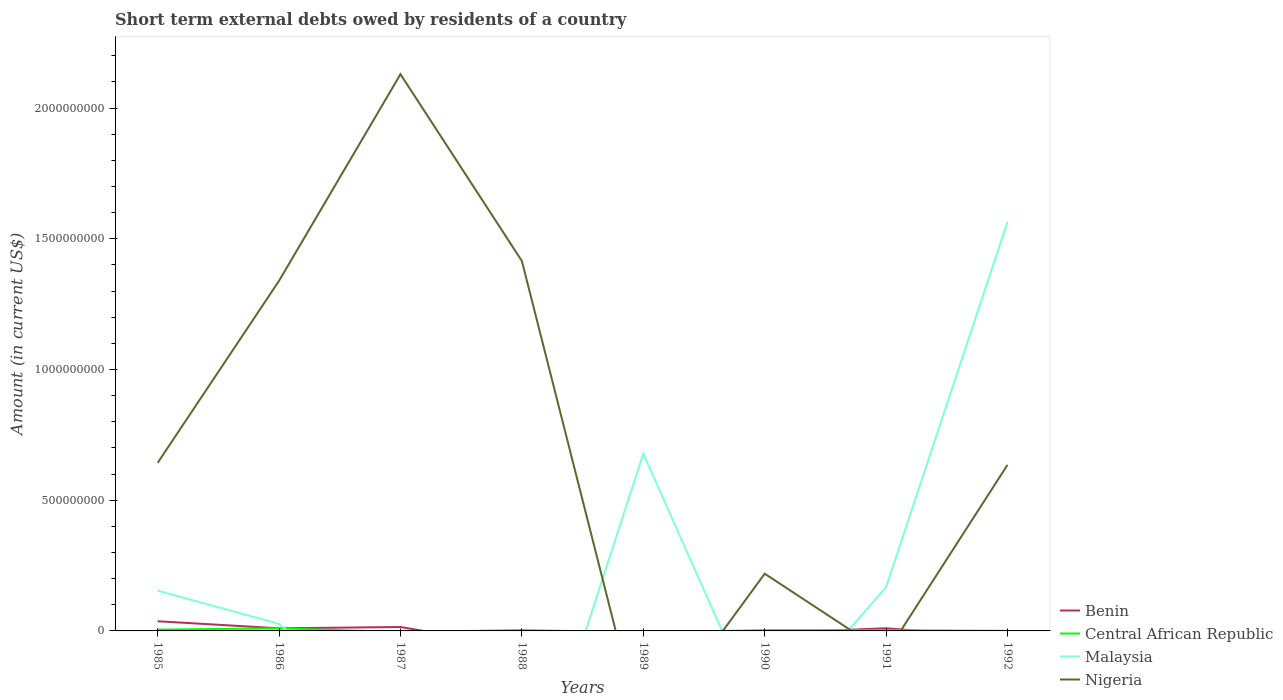Does the line corresponding to Nigeria intersect with the line corresponding to Central African Republic?
Make the answer very short. Yes. Across all years, what is the maximum amount of short-term external debts owed by residents in Benin?
Give a very brief answer. 0. What is the total amount of short-term external debts owed by residents in Benin in the graph?
Keep it short and to the point. -5.00e+06. What is the difference between the highest and the second highest amount of short-term external debts owed by residents in Central African Republic?
Your answer should be very brief. 1.00e+07. What is the difference between the highest and the lowest amount of short-term external debts owed by residents in Central African Republic?
Ensure brevity in your answer.  3. How many lines are there?
Provide a short and direct response. 4. How many years are there in the graph?
Your answer should be very brief. 8. What is the difference between two consecutive major ticks on the Y-axis?
Your answer should be very brief. 5.00e+08. Does the graph contain any zero values?
Give a very brief answer. Yes. Does the graph contain grids?
Offer a terse response. No. Where does the legend appear in the graph?
Your response must be concise. Bottom right. How many legend labels are there?
Provide a short and direct response. 4. What is the title of the graph?
Ensure brevity in your answer.  Short term external debts owed by residents of a country. What is the label or title of the Y-axis?
Make the answer very short. Amount (in current US$). What is the Amount (in current US$) of Benin in 1985?
Make the answer very short. 3.70e+07. What is the Amount (in current US$) in Central African Republic in 1985?
Your response must be concise. 5.00e+06. What is the Amount (in current US$) in Malaysia in 1985?
Provide a short and direct response. 1.54e+08. What is the Amount (in current US$) in Nigeria in 1985?
Offer a terse response. 6.43e+08. What is the Amount (in current US$) in Benin in 1986?
Make the answer very short. 1.00e+07. What is the Amount (in current US$) of Central African Republic in 1986?
Offer a very short reply. 1.00e+07. What is the Amount (in current US$) of Malaysia in 1986?
Give a very brief answer. 2.70e+07. What is the Amount (in current US$) of Nigeria in 1986?
Offer a terse response. 1.34e+09. What is the Amount (in current US$) of Benin in 1987?
Your answer should be compact. 1.50e+07. What is the Amount (in current US$) of Central African Republic in 1987?
Your answer should be very brief. 0. What is the Amount (in current US$) in Nigeria in 1987?
Your response must be concise. 2.13e+09. What is the Amount (in current US$) in Central African Republic in 1988?
Give a very brief answer. 3.33e+06. What is the Amount (in current US$) in Nigeria in 1988?
Your answer should be compact. 1.41e+09. What is the Amount (in current US$) of Central African Republic in 1989?
Your answer should be compact. 0. What is the Amount (in current US$) in Malaysia in 1989?
Your answer should be compact. 6.78e+08. What is the Amount (in current US$) of Benin in 1990?
Provide a short and direct response. 0. What is the Amount (in current US$) of Central African Republic in 1990?
Provide a succinct answer. 2.91e+06. What is the Amount (in current US$) of Nigeria in 1990?
Ensure brevity in your answer.  2.19e+08. What is the Amount (in current US$) in Benin in 1991?
Make the answer very short. 1.01e+07. What is the Amount (in current US$) in Central African Republic in 1991?
Ensure brevity in your answer.  3.00e+06. What is the Amount (in current US$) in Malaysia in 1991?
Give a very brief answer. 1.68e+08. What is the Amount (in current US$) of Nigeria in 1991?
Provide a succinct answer. 0. What is the Amount (in current US$) of Malaysia in 1992?
Your answer should be very brief. 1.57e+09. What is the Amount (in current US$) of Nigeria in 1992?
Offer a terse response. 6.35e+08. Across all years, what is the maximum Amount (in current US$) of Benin?
Your response must be concise. 3.70e+07. Across all years, what is the maximum Amount (in current US$) in Malaysia?
Your answer should be compact. 1.57e+09. Across all years, what is the maximum Amount (in current US$) of Nigeria?
Provide a succinct answer. 2.13e+09. Across all years, what is the minimum Amount (in current US$) in Malaysia?
Keep it short and to the point. 0. Across all years, what is the minimum Amount (in current US$) of Nigeria?
Keep it short and to the point. 0. What is the total Amount (in current US$) of Benin in the graph?
Provide a succinct answer. 7.21e+07. What is the total Amount (in current US$) in Central African Republic in the graph?
Your answer should be compact. 2.45e+07. What is the total Amount (in current US$) in Malaysia in the graph?
Provide a succinct answer. 2.59e+09. What is the total Amount (in current US$) of Nigeria in the graph?
Offer a very short reply. 6.38e+09. What is the difference between the Amount (in current US$) of Benin in 1985 and that in 1986?
Your answer should be very brief. 2.70e+07. What is the difference between the Amount (in current US$) in Central African Republic in 1985 and that in 1986?
Your answer should be compact. -5.00e+06. What is the difference between the Amount (in current US$) in Malaysia in 1985 and that in 1986?
Ensure brevity in your answer.  1.27e+08. What is the difference between the Amount (in current US$) of Nigeria in 1985 and that in 1986?
Give a very brief answer. -6.96e+08. What is the difference between the Amount (in current US$) of Benin in 1985 and that in 1987?
Provide a short and direct response. 2.20e+07. What is the difference between the Amount (in current US$) in Nigeria in 1985 and that in 1987?
Give a very brief answer. -1.49e+09. What is the difference between the Amount (in current US$) in Central African Republic in 1985 and that in 1988?
Provide a succinct answer. 1.67e+06. What is the difference between the Amount (in current US$) of Nigeria in 1985 and that in 1988?
Give a very brief answer. -7.72e+08. What is the difference between the Amount (in current US$) in Malaysia in 1985 and that in 1989?
Give a very brief answer. -5.24e+08. What is the difference between the Amount (in current US$) in Central African Republic in 1985 and that in 1990?
Give a very brief answer. 2.09e+06. What is the difference between the Amount (in current US$) in Nigeria in 1985 and that in 1990?
Offer a terse response. 4.24e+08. What is the difference between the Amount (in current US$) in Benin in 1985 and that in 1991?
Offer a terse response. 2.69e+07. What is the difference between the Amount (in current US$) in Malaysia in 1985 and that in 1991?
Offer a very short reply. -1.38e+07. What is the difference between the Amount (in current US$) of Central African Republic in 1985 and that in 1992?
Offer a very short reply. 4.70e+06. What is the difference between the Amount (in current US$) in Malaysia in 1985 and that in 1992?
Give a very brief answer. -1.41e+09. What is the difference between the Amount (in current US$) of Nigeria in 1985 and that in 1992?
Keep it short and to the point. 7.87e+06. What is the difference between the Amount (in current US$) in Benin in 1986 and that in 1987?
Your answer should be very brief. -5.00e+06. What is the difference between the Amount (in current US$) of Nigeria in 1986 and that in 1987?
Keep it short and to the point. -7.90e+08. What is the difference between the Amount (in current US$) in Central African Republic in 1986 and that in 1988?
Your answer should be compact. 6.67e+06. What is the difference between the Amount (in current US$) in Nigeria in 1986 and that in 1988?
Offer a very short reply. -7.55e+07. What is the difference between the Amount (in current US$) in Malaysia in 1986 and that in 1989?
Your response must be concise. -6.51e+08. What is the difference between the Amount (in current US$) of Central African Republic in 1986 and that in 1990?
Give a very brief answer. 7.09e+06. What is the difference between the Amount (in current US$) of Nigeria in 1986 and that in 1990?
Provide a short and direct response. 1.12e+09. What is the difference between the Amount (in current US$) in Malaysia in 1986 and that in 1991?
Make the answer very short. -1.41e+08. What is the difference between the Amount (in current US$) of Central African Republic in 1986 and that in 1992?
Make the answer very short. 9.70e+06. What is the difference between the Amount (in current US$) in Malaysia in 1986 and that in 1992?
Make the answer very short. -1.54e+09. What is the difference between the Amount (in current US$) of Nigeria in 1986 and that in 1992?
Give a very brief answer. 7.04e+08. What is the difference between the Amount (in current US$) in Nigeria in 1987 and that in 1988?
Ensure brevity in your answer.  7.15e+08. What is the difference between the Amount (in current US$) in Nigeria in 1987 and that in 1990?
Your response must be concise. 1.91e+09. What is the difference between the Amount (in current US$) in Benin in 1987 and that in 1991?
Ensure brevity in your answer.  4.89e+06. What is the difference between the Amount (in current US$) of Nigeria in 1987 and that in 1992?
Provide a short and direct response. 1.49e+09. What is the difference between the Amount (in current US$) of Nigeria in 1988 and that in 1990?
Offer a terse response. 1.20e+09. What is the difference between the Amount (in current US$) of Central African Republic in 1988 and that in 1992?
Your answer should be very brief. 3.03e+06. What is the difference between the Amount (in current US$) of Nigeria in 1988 and that in 1992?
Keep it short and to the point. 7.80e+08. What is the difference between the Amount (in current US$) of Malaysia in 1989 and that in 1991?
Your response must be concise. 5.10e+08. What is the difference between the Amount (in current US$) of Malaysia in 1989 and that in 1992?
Make the answer very short. -8.87e+08. What is the difference between the Amount (in current US$) of Central African Republic in 1990 and that in 1991?
Your answer should be very brief. -9.00e+04. What is the difference between the Amount (in current US$) of Central African Republic in 1990 and that in 1992?
Provide a short and direct response. 2.61e+06. What is the difference between the Amount (in current US$) of Nigeria in 1990 and that in 1992?
Offer a terse response. -4.16e+08. What is the difference between the Amount (in current US$) of Central African Republic in 1991 and that in 1992?
Keep it short and to the point. 2.70e+06. What is the difference between the Amount (in current US$) of Malaysia in 1991 and that in 1992?
Your response must be concise. -1.40e+09. What is the difference between the Amount (in current US$) of Benin in 1985 and the Amount (in current US$) of Central African Republic in 1986?
Provide a succinct answer. 2.70e+07. What is the difference between the Amount (in current US$) of Benin in 1985 and the Amount (in current US$) of Malaysia in 1986?
Your response must be concise. 1.00e+07. What is the difference between the Amount (in current US$) in Benin in 1985 and the Amount (in current US$) in Nigeria in 1986?
Give a very brief answer. -1.30e+09. What is the difference between the Amount (in current US$) of Central African Republic in 1985 and the Amount (in current US$) of Malaysia in 1986?
Your response must be concise. -2.20e+07. What is the difference between the Amount (in current US$) in Central African Republic in 1985 and the Amount (in current US$) in Nigeria in 1986?
Give a very brief answer. -1.33e+09. What is the difference between the Amount (in current US$) of Malaysia in 1985 and the Amount (in current US$) of Nigeria in 1986?
Provide a short and direct response. -1.19e+09. What is the difference between the Amount (in current US$) of Benin in 1985 and the Amount (in current US$) of Nigeria in 1987?
Keep it short and to the point. -2.09e+09. What is the difference between the Amount (in current US$) in Central African Republic in 1985 and the Amount (in current US$) in Nigeria in 1987?
Offer a very short reply. -2.12e+09. What is the difference between the Amount (in current US$) of Malaysia in 1985 and the Amount (in current US$) of Nigeria in 1987?
Provide a succinct answer. -1.98e+09. What is the difference between the Amount (in current US$) in Benin in 1985 and the Amount (in current US$) in Central African Republic in 1988?
Provide a short and direct response. 3.37e+07. What is the difference between the Amount (in current US$) in Benin in 1985 and the Amount (in current US$) in Nigeria in 1988?
Provide a short and direct response. -1.38e+09. What is the difference between the Amount (in current US$) of Central African Republic in 1985 and the Amount (in current US$) of Nigeria in 1988?
Make the answer very short. -1.41e+09. What is the difference between the Amount (in current US$) of Malaysia in 1985 and the Amount (in current US$) of Nigeria in 1988?
Provide a short and direct response. -1.26e+09. What is the difference between the Amount (in current US$) in Benin in 1985 and the Amount (in current US$) in Malaysia in 1989?
Your response must be concise. -6.41e+08. What is the difference between the Amount (in current US$) of Central African Republic in 1985 and the Amount (in current US$) of Malaysia in 1989?
Offer a terse response. -6.73e+08. What is the difference between the Amount (in current US$) in Benin in 1985 and the Amount (in current US$) in Central African Republic in 1990?
Ensure brevity in your answer.  3.41e+07. What is the difference between the Amount (in current US$) of Benin in 1985 and the Amount (in current US$) of Nigeria in 1990?
Provide a succinct answer. -1.82e+08. What is the difference between the Amount (in current US$) of Central African Republic in 1985 and the Amount (in current US$) of Nigeria in 1990?
Provide a short and direct response. -2.14e+08. What is the difference between the Amount (in current US$) in Malaysia in 1985 and the Amount (in current US$) in Nigeria in 1990?
Offer a very short reply. -6.49e+07. What is the difference between the Amount (in current US$) of Benin in 1985 and the Amount (in current US$) of Central African Republic in 1991?
Provide a short and direct response. 3.40e+07. What is the difference between the Amount (in current US$) of Benin in 1985 and the Amount (in current US$) of Malaysia in 1991?
Give a very brief answer. -1.31e+08. What is the difference between the Amount (in current US$) of Central African Republic in 1985 and the Amount (in current US$) of Malaysia in 1991?
Give a very brief answer. -1.63e+08. What is the difference between the Amount (in current US$) in Benin in 1985 and the Amount (in current US$) in Central African Republic in 1992?
Offer a very short reply. 3.67e+07. What is the difference between the Amount (in current US$) of Benin in 1985 and the Amount (in current US$) of Malaysia in 1992?
Your response must be concise. -1.53e+09. What is the difference between the Amount (in current US$) of Benin in 1985 and the Amount (in current US$) of Nigeria in 1992?
Offer a terse response. -5.98e+08. What is the difference between the Amount (in current US$) in Central African Republic in 1985 and the Amount (in current US$) in Malaysia in 1992?
Your response must be concise. -1.56e+09. What is the difference between the Amount (in current US$) in Central African Republic in 1985 and the Amount (in current US$) in Nigeria in 1992?
Make the answer very short. -6.30e+08. What is the difference between the Amount (in current US$) of Malaysia in 1985 and the Amount (in current US$) of Nigeria in 1992?
Your answer should be compact. -4.81e+08. What is the difference between the Amount (in current US$) of Benin in 1986 and the Amount (in current US$) of Nigeria in 1987?
Your answer should be compact. -2.12e+09. What is the difference between the Amount (in current US$) in Central African Republic in 1986 and the Amount (in current US$) in Nigeria in 1987?
Ensure brevity in your answer.  -2.12e+09. What is the difference between the Amount (in current US$) of Malaysia in 1986 and the Amount (in current US$) of Nigeria in 1987?
Give a very brief answer. -2.10e+09. What is the difference between the Amount (in current US$) of Benin in 1986 and the Amount (in current US$) of Central African Republic in 1988?
Your answer should be very brief. 6.67e+06. What is the difference between the Amount (in current US$) of Benin in 1986 and the Amount (in current US$) of Nigeria in 1988?
Provide a short and direct response. -1.40e+09. What is the difference between the Amount (in current US$) in Central African Republic in 1986 and the Amount (in current US$) in Nigeria in 1988?
Your response must be concise. -1.40e+09. What is the difference between the Amount (in current US$) in Malaysia in 1986 and the Amount (in current US$) in Nigeria in 1988?
Your response must be concise. -1.39e+09. What is the difference between the Amount (in current US$) of Benin in 1986 and the Amount (in current US$) of Malaysia in 1989?
Offer a terse response. -6.68e+08. What is the difference between the Amount (in current US$) in Central African Republic in 1986 and the Amount (in current US$) in Malaysia in 1989?
Ensure brevity in your answer.  -6.68e+08. What is the difference between the Amount (in current US$) of Benin in 1986 and the Amount (in current US$) of Central African Republic in 1990?
Keep it short and to the point. 7.09e+06. What is the difference between the Amount (in current US$) in Benin in 1986 and the Amount (in current US$) in Nigeria in 1990?
Make the answer very short. -2.09e+08. What is the difference between the Amount (in current US$) in Central African Republic in 1986 and the Amount (in current US$) in Nigeria in 1990?
Your answer should be very brief. -2.09e+08. What is the difference between the Amount (in current US$) in Malaysia in 1986 and the Amount (in current US$) in Nigeria in 1990?
Your answer should be compact. -1.92e+08. What is the difference between the Amount (in current US$) of Benin in 1986 and the Amount (in current US$) of Central African Republic in 1991?
Ensure brevity in your answer.  7.00e+06. What is the difference between the Amount (in current US$) in Benin in 1986 and the Amount (in current US$) in Malaysia in 1991?
Give a very brief answer. -1.58e+08. What is the difference between the Amount (in current US$) in Central African Republic in 1986 and the Amount (in current US$) in Malaysia in 1991?
Make the answer very short. -1.58e+08. What is the difference between the Amount (in current US$) of Benin in 1986 and the Amount (in current US$) of Central African Republic in 1992?
Offer a very short reply. 9.70e+06. What is the difference between the Amount (in current US$) of Benin in 1986 and the Amount (in current US$) of Malaysia in 1992?
Provide a succinct answer. -1.56e+09. What is the difference between the Amount (in current US$) of Benin in 1986 and the Amount (in current US$) of Nigeria in 1992?
Offer a terse response. -6.25e+08. What is the difference between the Amount (in current US$) in Central African Republic in 1986 and the Amount (in current US$) in Malaysia in 1992?
Offer a very short reply. -1.56e+09. What is the difference between the Amount (in current US$) in Central African Republic in 1986 and the Amount (in current US$) in Nigeria in 1992?
Your answer should be compact. -6.25e+08. What is the difference between the Amount (in current US$) in Malaysia in 1986 and the Amount (in current US$) in Nigeria in 1992?
Your answer should be compact. -6.08e+08. What is the difference between the Amount (in current US$) in Benin in 1987 and the Amount (in current US$) in Central African Republic in 1988?
Your response must be concise. 1.17e+07. What is the difference between the Amount (in current US$) of Benin in 1987 and the Amount (in current US$) of Nigeria in 1988?
Offer a terse response. -1.40e+09. What is the difference between the Amount (in current US$) of Benin in 1987 and the Amount (in current US$) of Malaysia in 1989?
Your answer should be very brief. -6.63e+08. What is the difference between the Amount (in current US$) of Benin in 1987 and the Amount (in current US$) of Central African Republic in 1990?
Provide a short and direct response. 1.21e+07. What is the difference between the Amount (in current US$) of Benin in 1987 and the Amount (in current US$) of Nigeria in 1990?
Make the answer very short. -2.04e+08. What is the difference between the Amount (in current US$) in Benin in 1987 and the Amount (in current US$) in Malaysia in 1991?
Offer a terse response. -1.53e+08. What is the difference between the Amount (in current US$) of Benin in 1987 and the Amount (in current US$) of Central African Republic in 1992?
Provide a short and direct response. 1.47e+07. What is the difference between the Amount (in current US$) in Benin in 1987 and the Amount (in current US$) in Malaysia in 1992?
Offer a terse response. -1.55e+09. What is the difference between the Amount (in current US$) in Benin in 1987 and the Amount (in current US$) in Nigeria in 1992?
Make the answer very short. -6.20e+08. What is the difference between the Amount (in current US$) of Central African Republic in 1988 and the Amount (in current US$) of Malaysia in 1989?
Give a very brief answer. -6.75e+08. What is the difference between the Amount (in current US$) of Central African Republic in 1988 and the Amount (in current US$) of Nigeria in 1990?
Make the answer very short. -2.16e+08. What is the difference between the Amount (in current US$) in Central African Republic in 1988 and the Amount (in current US$) in Malaysia in 1991?
Keep it short and to the point. -1.65e+08. What is the difference between the Amount (in current US$) of Central African Republic in 1988 and the Amount (in current US$) of Malaysia in 1992?
Make the answer very short. -1.56e+09. What is the difference between the Amount (in current US$) of Central African Republic in 1988 and the Amount (in current US$) of Nigeria in 1992?
Ensure brevity in your answer.  -6.32e+08. What is the difference between the Amount (in current US$) in Malaysia in 1989 and the Amount (in current US$) in Nigeria in 1990?
Your answer should be very brief. 4.59e+08. What is the difference between the Amount (in current US$) in Malaysia in 1989 and the Amount (in current US$) in Nigeria in 1992?
Provide a succinct answer. 4.28e+07. What is the difference between the Amount (in current US$) in Central African Republic in 1990 and the Amount (in current US$) in Malaysia in 1991?
Your answer should be very brief. -1.65e+08. What is the difference between the Amount (in current US$) in Central African Republic in 1990 and the Amount (in current US$) in Malaysia in 1992?
Your answer should be compact. -1.56e+09. What is the difference between the Amount (in current US$) in Central African Republic in 1990 and the Amount (in current US$) in Nigeria in 1992?
Your answer should be very brief. -6.32e+08. What is the difference between the Amount (in current US$) of Benin in 1991 and the Amount (in current US$) of Central African Republic in 1992?
Ensure brevity in your answer.  9.81e+06. What is the difference between the Amount (in current US$) in Benin in 1991 and the Amount (in current US$) in Malaysia in 1992?
Make the answer very short. -1.56e+09. What is the difference between the Amount (in current US$) of Benin in 1991 and the Amount (in current US$) of Nigeria in 1992?
Your response must be concise. -6.25e+08. What is the difference between the Amount (in current US$) in Central African Republic in 1991 and the Amount (in current US$) in Malaysia in 1992?
Make the answer very short. -1.56e+09. What is the difference between the Amount (in current US$) of Central African Republic in 1991 and the Amount (in current US$) of Nigeria in 1992?
Offer a very short reply. -6.32e+08. What is the difference between the Amount (in current US$) of Malaysia in 1991 and the Amount (in current US$) of Nigeria in 1992?
Provide a short and direct response. -4.67e+08. What is the average Amount (in current US$) in Benin per year?
Provide a short and direct response. 9.01e+06. What is the average Amount (in current US$) of Central African Republic per year?
Give a very brief answer. 3.07e+06. What is the average Amount (in current US$) in Malaysia per year?
Keep it short and to the point. 3.24e+08. What is the average Amount (in current US$) in Nigeria per year?
Keep it short and to the point. 7.98e+08. In the year 1985, what is the difference between the Amount (in current US$) in Benin and Amount (in current US$) in Central African Republic?
Make the answer very short. 3.20e+07. In the year 1985, what is the difference between the Amount (in current US$) of Benin and Amount (in current US$) of Malaysia?
Offer a terse response. -1.17e+08. In the year 1985, what is the difference between the Amount (in current US$) of Benin and Amount (in current US$) of Nigeria?
Offer a terse response. -6.06e+08. In the year 1985, what is the difference between the Amount (in current US$) in Central African Republic and Amount (in current US$) in Malaysia?
Ensure brevity in your answer.  -1.49e+08. In the year 1985, what is the difference between the Amount (in current US$) of Central African Republic and Amount (in current US$) of Nigeria?
Your answer should be very brief. -6.38e+08. In the year 1985, what is the difference between the Amount (in current US$) of Malaysia and Amount (in current US$) of Nigeria?
Provide a short and direct response. -4.89e+08. In the year 1986, what is the difference between the Amount (in current US$) of Benin and Amount (in current US$) of Malaysia?
Provide a short and direct response. -1.70e+07. In the year 1986, what is the difference between the Amount (in current US$) of Benin and Amount (in current US$) of Nigeria?
Ensure brevity in your answer.  -1.33e+09. In the year 1986, what is the difference between the Amount (in current US$) of Central African Republic and Amount (in current US$) of Malaysia?
Offer a terse response. -1.70e+07. In the year 1986, what is the difference between the Amount (in current US$) in Central African Republic and Amount (in current US$) in Nigeria?
Make the answer very short. -1.33e+09. In the year 1986, what is the difference between the Amount (in current US$) of Malaysia and Amount (in current US$) of Nigeria?
Your answer should be very brief. -1.31e+09. In the year 1987, what is the difference between the Amount (in current US$) of Benin and Amount (in current US$) of Nigeria?
Provide a succinct answer. -2.11e+09. In the year 1988, what is the difference between the Amount (in current US$) in Central African Republic and Amount (in current US$) in Nigeria?
Provide a short and direct response. -1.41e+09. In the year 1990, what is the difference between the Amount (in current US$) in Central African Republic and Amount (in current US$) in Nigeria?
Your answer should be compact. -2.16e+08. In the year 1991, what is the difference between the Amount (in current US$) of Benin and Amount (in current US$) of Central African Republic?
Offer a terse response. 7.11e+06. In the year 1991, what is the difference between the Amount (in current US$) in Benin and Amount (in current US$) in Malaysia?
Keep it short and to the point. -1.58e+08. In the year 1991, what is the difference between the Amount (in current US$) of Central African Republic and Amount (in current US$) of Malaysia?
Keep it short and to the point. -1.65e+08. In the year 1992, what is the difference between the Amount (in current US$) of Central African Republic and Amount (in current US$) of Malaysia?
Your answer should be very brief. -1.56e+09. In the year 1992, what is the difference between the Amount (in current US$) of Central African Republic and Amount (in current US$) of Nigeria?
Your answer should be compact. -6.35e+08. In the year 1992, what is the difference between the Amount (in current US$) of Malaysia and Amount (in current US$) of Nigeria?
Your response must be concise. 9.30e+08. What is the ratio of the Amount (in current US$) in Benin in 1985 to that in 1986?
Offer a very short reply. 3.7. What is the ratio of the Amount (in current US$) in Central African Republic in 1985 to that in 1986?
Your answer should be compact. 0.5. What is the ratio of the Amount (in current US$) in Malaysia in 1985 to that in 1986?
Your response must be concise. 5.7. What is the ratio of the Amount (in current US$) in Nigeria in 1985 to that in 1986?
Your answer should be compact. 0.48. What is the ratio of the Amount (in current US$) in Benin in 1985 to that in 1987?
Your response must be concise. 2.47. What is the ratio of the Amount (in current US$) of Nigeria in 1985 to that in 1987?
Your answer should be very brief. 0.3. What is the ratio of the Amount (in current US$) in Central African Republic in 1985 to that in 1988?
Provide a short and direct response. 1.5. What is the ratio of the Amount (in current US$) in Nigeria in 1985 to that in 1988?
Your answer should be very brief. 0.45. What is the ratio of the Amount (in current US$) of Malaysia in 1985 to that in 1989?
Provide a short and direct response. 0.23. What is the ratio of the Amount (in current US$) in Central African Republic in 1985 to that in 1990?
Provide a succinct answer. 1.72. What is the ratio of the Amount (in current US$) of Nigeria in 1985 to that in 1990?
Provide a succinct answer. 2.94. What is the ratio of the Amount (in current US$) of Benin in 1985 to that in 1991?
Offer a very short reply. 3.66. What is the ratio of the Amount (in current US$) in Central African Republic in 1985 to that in 1991?
Offer a very short reply. 1.67. What is the ratio of the Amount (in current US$) in Malaysia in 1985 to that in 1991?
Offer a terse response. 0.92. What is the ratio of the Amount (in current US$) in Central African Republic in 1985 to that in 1992?
Provide a succinct answer. 16.67. What is the ratio of the Amount (in current US$) in Malaysia in 1985 to that in 1992?
Provide a succinct answer. 0.1. What is the ratio of the Amount (in current US$) in Nigeria in 1985 to that in 1992?
Ensure brevity in your answer.  1.01. What is the ratio of the Amount (in current US$) of Nigeria in 1986 to that in 1987?
Make the answer very short. 0.63. What is the ratio of the Amount (in current US$) of Central African Republic in 1986 to that in 1988?
Make the answer very short. 3. What is the ratio of the Amount (in current US$) in Nigeria in 1986 to that in 1988?
Ensure brevity in your answer.  0.95. What is the ratio of the Amount (in current US$) of Malaysia in 1986 to that in 1989?
Ensure brevity in your answer.  0.04. What is the ratio of the Amount (in current US$) in Central African Republic in 1986 to that in 1990?
Provide a short and direct response. 3.44. What is the ratio of the Amount (in current US$) in Nigeria in 1986 to that in 1990?
Keep it short and to the point. 6.12. What is the ratio of the Amount (in current US$) of Malaysia in 1986 to that in 1991?
Keep it short and to the point. 0.16. What is the ratio of the Amount (in current US$) of Central African Republic in 1986 to that in 1992?
Your response must be concise. 33.33. What is the ratio of the Amount (in current US$) in Malaysia in 1986 to that in 1992?
Offer a very short reply. 0.02. What is the ratio of the Amount (in current US$) in Nigeria in 1986 to that in 1992?
Offer a terse response. 2.11. What is the ratio of the Amount (in current US$) in Nigeria in 1987 to that in 1988?
Your answer should be compact. 1.51. What is the ratio of the Amount (in current US$) of Nigeria in 1987 to that in 1990?
Provide a short and direct response. 9.73. What is the ratio of the Amount (in current US$) in Benin in 1987 to that in 1991?
Ensure brevity in your answer.  1.48. What is the ratio of the Amount (in current US$) of Nigeria in 1987 to that in 1992?
Your answer should be very brief. 3.35. What is the ratio of the Amount (in current US$) of Central African Republic in 1988 to that in 1990?
Keep it short and to the point. 1.14. What is the ratio of the Amount (in current US$) in Nigeria in 1988 to that in 1990?
Offer a terse response. 6.46. What is the ratio of the Amount (in current US$) in Central African Republic in 1988 to that in 1991?
Your answer should be very brief. 1.11. What is the ratio of the Amount (in current US$) in Central African Republic in 1988 to that in 1992?
Your response must be concise. 11.1. What is the ratio of the Amount (in current US$) in Nigeria in 1988 to that in 1992?
Make the answer very short. 2.23. What is the ratio of the Amount (in current US$) in Malaysia in 1989 to that in 1991?
Your answer should be very brief. 4.04. What is the ratio of the Amount (in current US$) of Malaysia in 1989 to that in 1992?
Offer a very short reply. 0.43. What is the ratio of the Amount (in current US$) of Central African Republic in 1990 to that in 1991?
Offer a very short reply. 0.97. What is the ratio of the Amount (in current US$) of Nigeria in 1990 to that in 1992?
Give a very brief answer. 0.34. What is the ratio of the Amount (in current US$) of Malaysia in 1991 to that in 1992?
Keep it short and to the point. 0.11. What is the difference between the highest and the second highest Amount (in current US$) of Benin?
Ensure brevity in your answer.  2.20e+07. What is the difference between the highest and the second highest Amount (in current US$) of Central African Republic?
Provide a short and direct response. 5.00e+06. What is the difference between the highest and the second highest Amount (in current US$) of Malaysia?
Give a very brief answer. 8.87e+08. What is the difference between the highest and the second highest Amount (in current US$) in Nigeria?
Ensure brevity in your answer.  7.15e+08. What is the difference between the highest and the lowest Amount (in current US$) in Benin?
Give a very brief answer. 3.70e+07. What is the difference between the highest and the lowest Amount (in current US$) in Central African Republic?
Keep it short and to the point. 1.00e+07. What is the difference between the highest and the lowest Amount (in current US$) in Malaysia?
Offer a terse response. 1.57e+09. What is the difference between the highest and the lowest Amount (in current US$) of Nigeria?
Your answer should be very brief. 2.13e+09. 